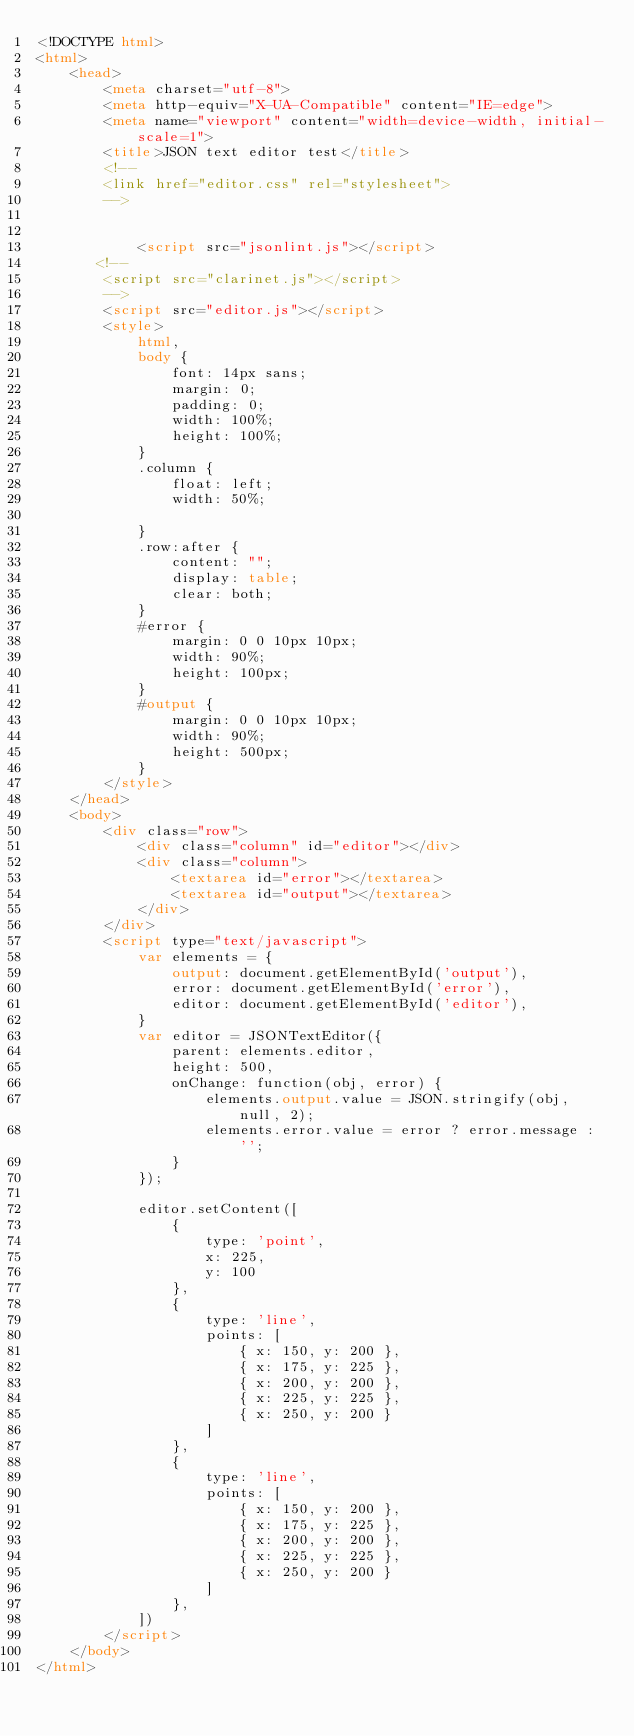<code> <loc_0><loc_0><loc_500><loc_500><_HTML_><!DOCTYPE html>
<html>
    <head>
        <meta charset="utf-8">
        <meta http-equiv="X-UA-Compatible" content="IE=edge">
        <meta name="viewport" content="width=device-width, initial-scale=1">
        <title>JSON text editor test</title>
        <!--
        <link href="editor.css" rel="stylesheet">
        -->
        
       
            <script src="jsonlint.js"></script>
       <!--
        <script src="clarinet.js"></script>
        -->
        <script src="editor.js"></script>
        <style>
            html, 
            body {
                font: 14px sans;                
                margin: 0;
                padding: 0;
                width: 100%;
                height: 100%;
            }            
            .column {
                float: left;
                width: 50%;

            }
            .row:after {
                content: "";
                display: table;
                clear: both;
            }
            #error {
                margin: 0 0 10px 10px;
                width: 90%;
                height: 100px;
            }            
            #output {
                margin: 0 0 10px 10px;
                width: 90%;
                height: 500px;
            }
        </style>        
    </head>
    <body>
        <div class="row">
            <div class="column" id="editor"></div>
            <div class="column">
                <textarea id="error"></textarea>
                <textarea id="output"></textarea>                        
            </div>
        </div>
        <script type="text/javascript">
            var elements = {
                output: document.getElementById('output'),
                error: document.getElementById('error'),
                editor: document.getElementById('editor'),
            }
            var editor = JSONTextEditor({
                parent: elements.editor,
                height: 500,
                onChange: function(obj, error) {
                    elements.output.value = JSON.stringify(obj, null, 2);
                    elements.error.value = error ? error.message : '';
                }
            });

            editor.setContent([
                { 
                    type: 'point',
                    x: 225, 
                    y: 100
                },
                {
                    type: 'line',
                    points: [
                        { x: 150, y: 200 },
                        { x: 175, y: 225 },
                        { x: 200, y: 200 },
                        { x: 225, y: 225 },
                        { x: 250, y: 200 }
                    ]
                },                
                {
                    type: 'line',
                    points: [
                        { x: 150, y: 200 },
                        { x: 175, y: 225 },
                        { x: 200, y: 200 },
                        { x: 225, y: 225 },
                        { x: 250, y: 200 }
                    ]
                },               
            ])
        </script>
    </body>
</html>
</code> 